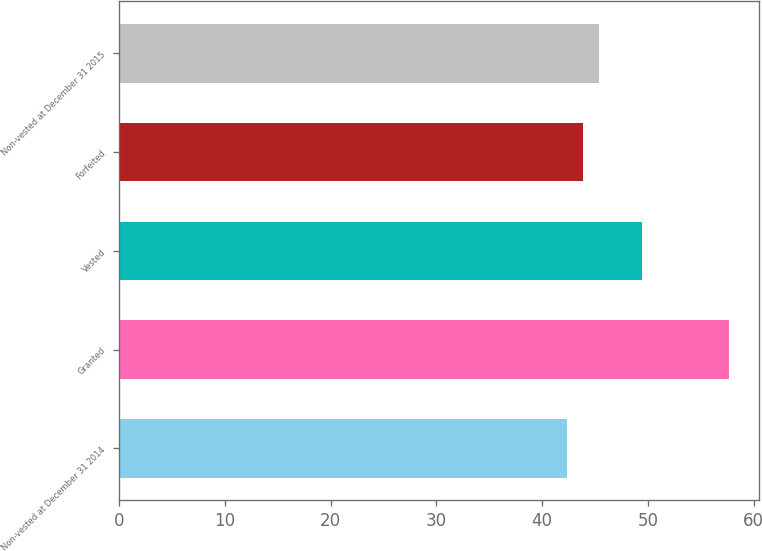<chart> <loc_0><loc_0><loc_500><loc_500><bar_chart><fcel>Non-vested at December 31 2014<fcel>Granted<fcel>Vested<fcel>Forfeited<fcel>Non-vested at December 31 2015<nl><fcel>42.33<fcel>57.67<fcel>49.45<fcel>43.86<fcel>45.39<nl></chart> 